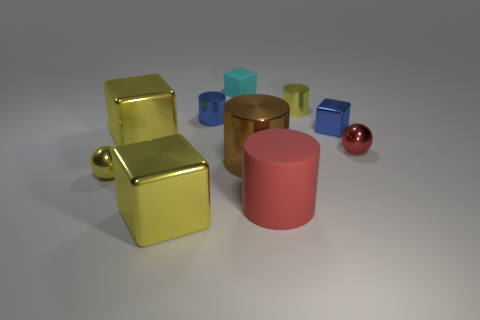Subtract all large brown cylinders. How many cylinders are left? 3 Subtract all yellow blocks. How many blocks are left? 2 Subtract all blocks. How many objects are left? 6 Subtract 3 cylinders. How many cylinders are left? 1 Add 1 purple metal balls. How many purple metal balls exist? 1 Subtract 1 blue cubes. How many objects are left? 9 Subtract all cyan cylinders. Subtract all brown cubes. How many cylinders are left? 4 Subtract all blue cylinders. How many red spheres are left? 1 Subtract all tiny yellow balls. Subtract all brown objects. How many objects are left? 8 Add 8 yellow shiny cylinders. How many yellow shiny cylinders are left? 9 